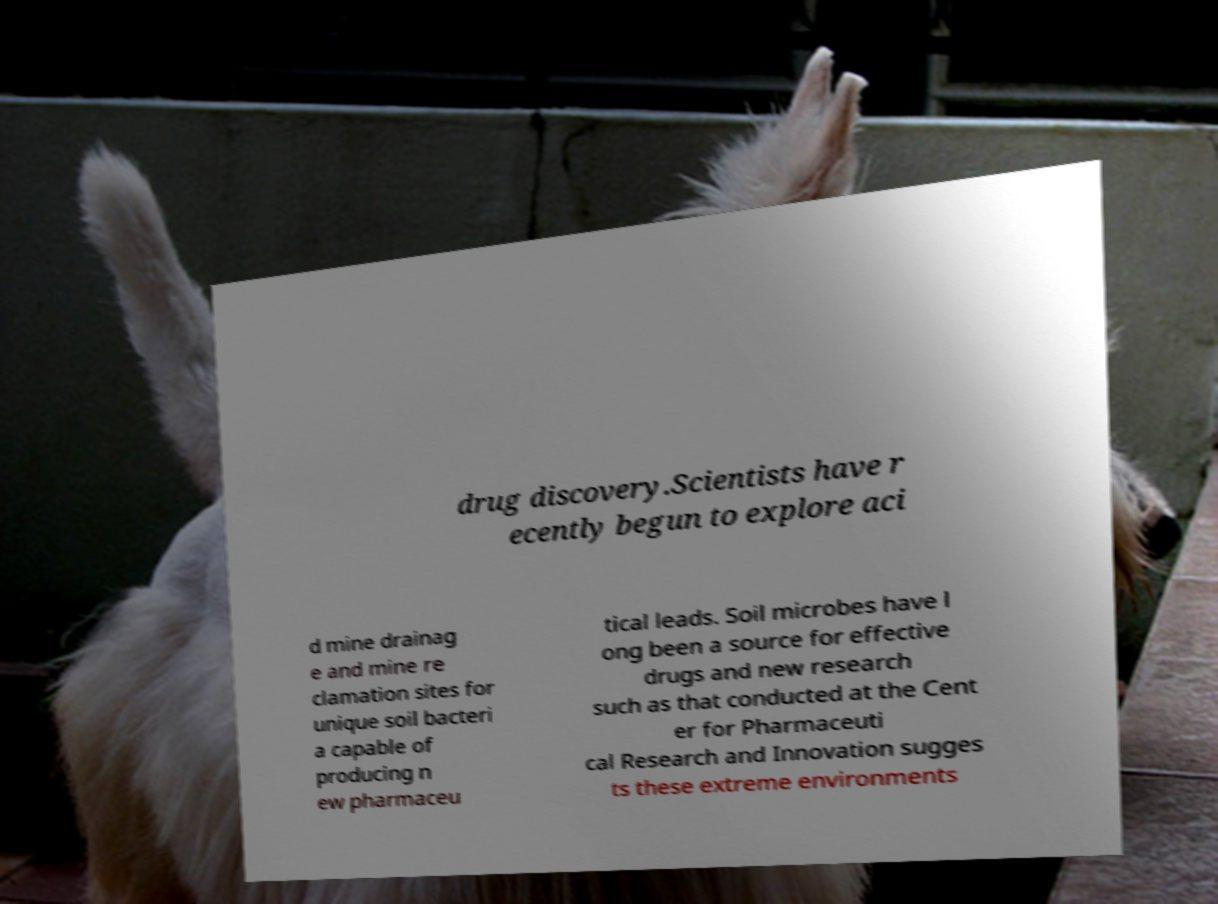What messages or text are displayed in this image? I need them in a readable, typed format. drug discovery.Scientists have r ecently begun to explore aci d mine drainag e and mine re clamation sites for unique soil bacteri a capable of producing n ew pharmaceu tical leads. Soil microbes have l ong been a source for effective drugs and new research such as that conducted at the Cent er for Pharmaceuti cal Research and Innovation sugges ts these extreme environments 